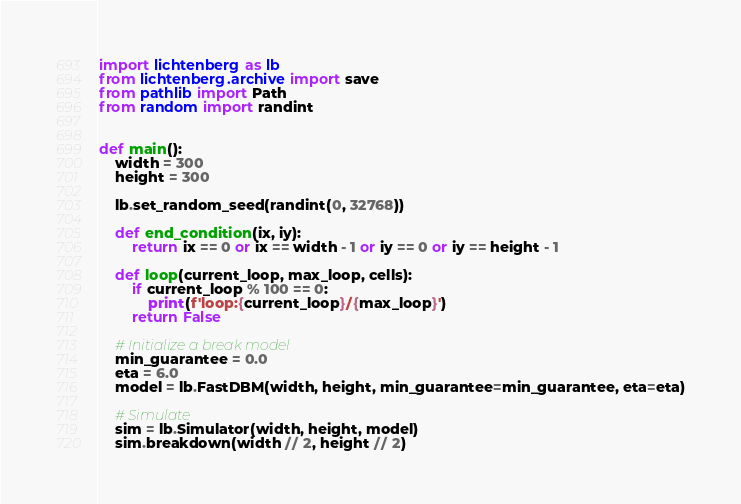<code> <loc_0><loc_0><loc_500><loc_500><_Python_>import lichtenberg as lb
from lichtenberg.archive import save
from pathlib import Path
from random import randint


def main():
    width = 300
    height = 300

    lb.set_random_seed(randint(0, 32768))
    
    def end_condition(ix, iy):
        return ix == 0 or ix == width - 1 or iy == 0 or iy == height - 1

    def loop(current_loop, max_loop, cells):
        if current_loop % 100 == 0:
            print(f'loop:{current_loop}/{max_loop}')
        return False

    # Initialize a break model
    min_guarantee = 0.0
    eta = 6.0
    model = lb.FastDBM(width, height, min_guarantee=min_guarantee, eta=eta)

    # Simulate
    sim = lb.Simulator(width, height, model)
    sim.breakdown(width // 2, height // 2)</code> 